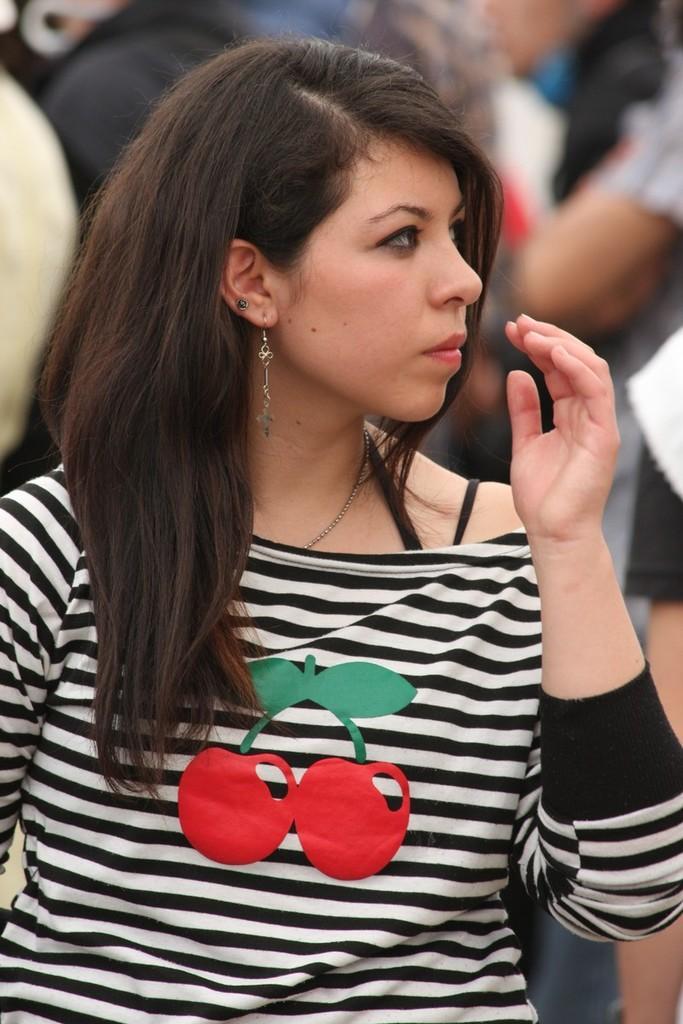In one or two sentences, can you explain what this image depicts? Here in this picture we can see a woman standing over a place and we can see she is wearing a black and white colored t shirt and in the middle of it we can see some fruits present and behind her we can see everything in blurry manner. 